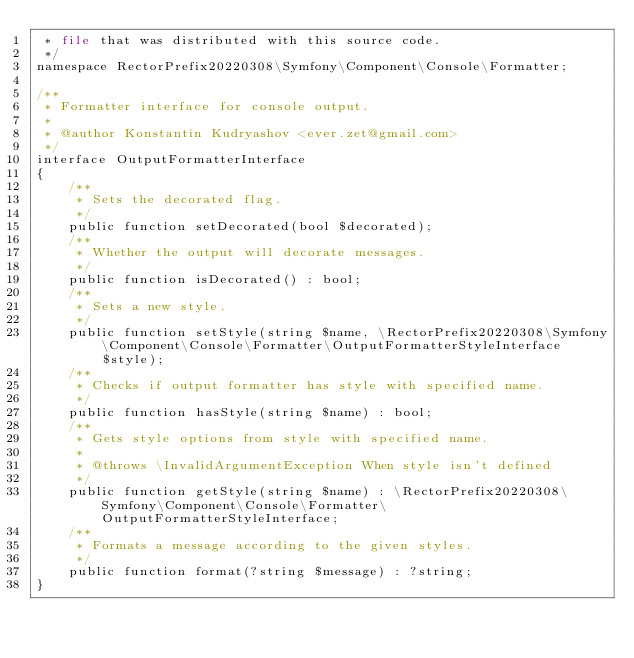Convert code to text. <code><loc_0><loc_0><loc_500><loc_500><_PHP_> * file that was distributed with this source code.
 */
namespace RectorPrefix20220308\Symfony\Component\Console\Formatter;

/**
 * Formatter interface for console output.
 *
 * @author Konstantin Kudryashov <ever.zet@gmail.com>
 */
interface OutputFormatterInterface
{
    /**
     * Sets the decorated flag.
     */
    public function setDecorated(bool $decorated);
    /**
     * Whether the output will decorate messages.
     */
    public function isDecorated() : bool;
    /**
     * Sets a new style.
     */
    public function setStyle(string $name, \RectorPrefix20220308\Symfony\Component\Console\Formatter\OutputFormatterStyleInterface $style);
    /**
     * Checks if output formatter has style with specified name.
     */
    public function hasStyle(string $name) : bool;
    /**
     * Gets style options from style with specified name.
     *
     * @throws \InvalidArgumentException When style isn't defined
     */
    public function getStyle(string $name) : \RectorPrefix20220308\Symfony\Component\Console\Formatter\OutputFormatterStyleInterface;
    /**
     * Formats a message according to the given styles.
     */
    public function format(?string $message) : ?string;
}
</code> 